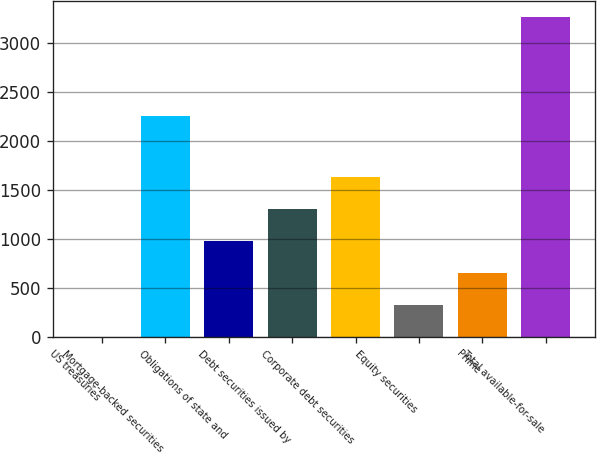Convert chart to OTSL. <chart><loc_0><loc_0><loc_500><loc_500><bar_chart><fcel>US treasuries<fcel>Mortgage-backed securities<fcel>Obligations of state and<fcel>Debt securities issued by<fcel>Corporate debt securities<fcel>Equity securities<fcel>Prime<fcel>Total available-for-sale<nl><fcel>2<fcel>2257<fcel>980.6<fcel>1306.8<fcel>1633<fcel>328.2<fcel>654.4<fcel>3264<nl></chart> 